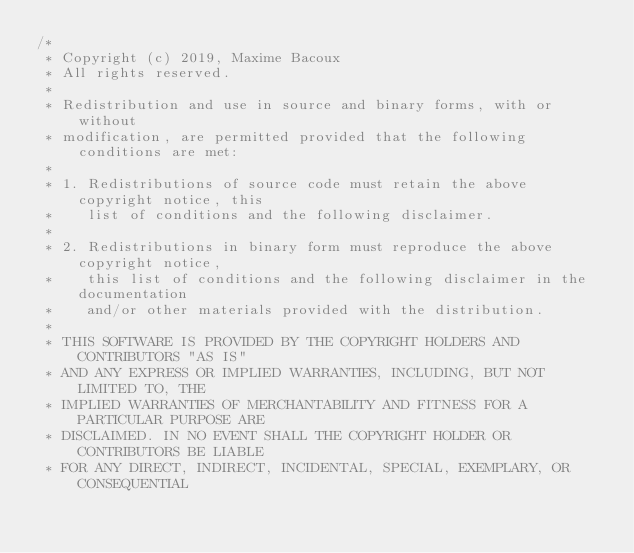Convert code to text. <code><loc_0><loc_0><loc_500><loc_500><_C_>/*
 * Copyright (c) 2019, Maxime Bacoux
 * All rights reserved.
 *
 * Redistribution and use in source and binary forms, with or without
 * modification, are permitted provided that the following conditions are met:
 *
 * 1. Redistributions of source code must retain the above copyright notice, this
 *    list of conditions and the following disclaimer.
 *
 * 2. Redistributions in binary form must reproduce the above copyright notice,
 *    this list of conditions and the following disclaimer in the documentation
 *    and/or other materials provided with the distribution.
 *
 * THIS SOFTWARE IS PROVIDED BY THE COPYRIGHT HOLDERS AND CONTRIBUTORS "AS IS"
 * AND ANY EXPRESS OR IMPLIED WARRANTIES, INCLUDING, BUT NOT LIMITED TO, THE
 * IMPLIED WARRANTIES OF MERCHANTABILITY AND FITNESS FOR A PARTICULAR PURPOSE ARE
 * DISCLAIMED. IN NO EVENT SHALL THE COPYRIGHT HOLDER OR CONTRIBUTORS BE LIABLE
 * FOR ANY DIRECT, INDIRECT, INCIDENTAL, SPECIAL, EXEMPLARY, OR CONSEQUENTIAL</code> 